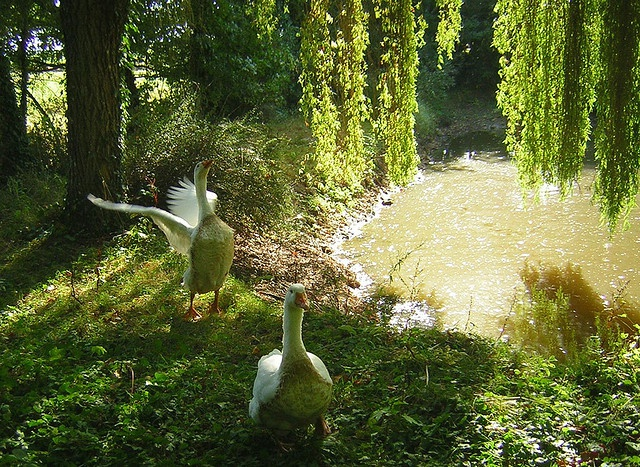Describe the objects in this image and their specific colors. I can see bird in black, darkgreen, darkgray, and gray tones and bird in black, darkgreen, and gray tones in this image. 